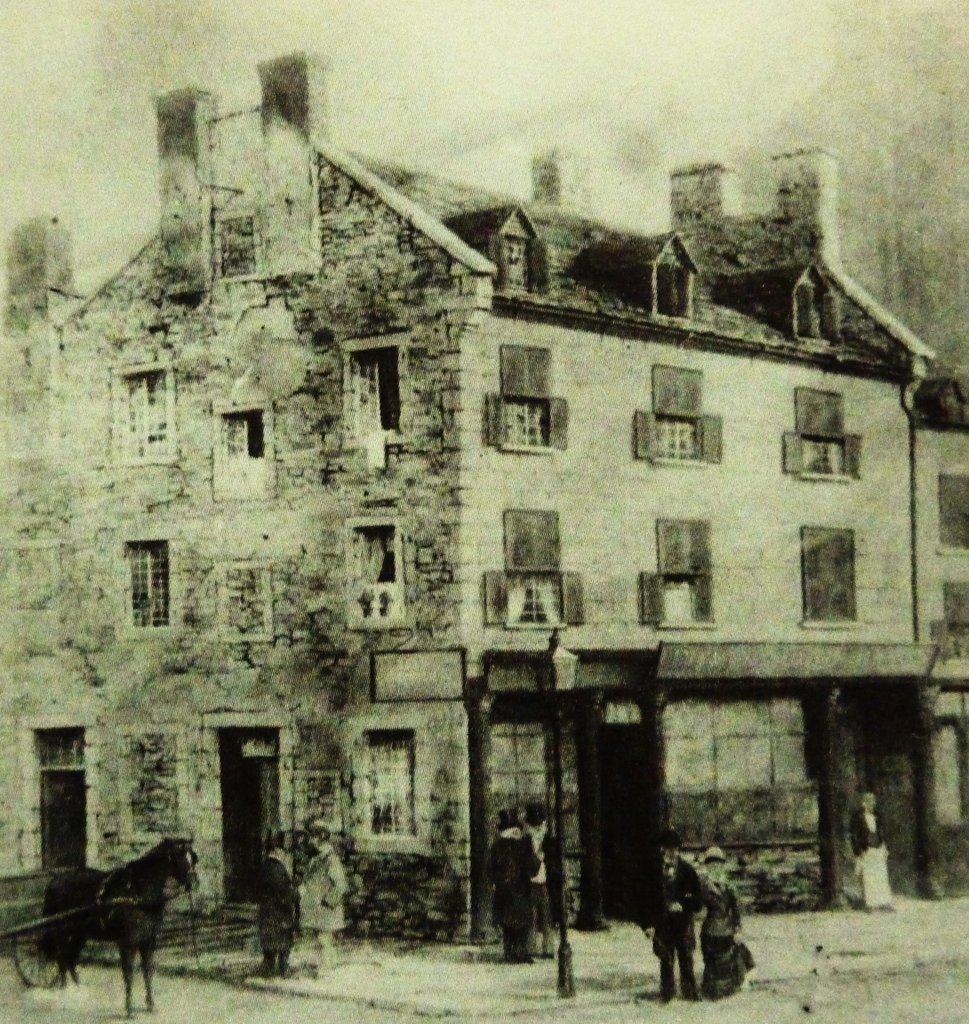Could you give a brief overview of what you see in this image? In this image I can see few people standing in-front of the building. I can also see the light pole to the side of these people. To the left I can see an animal. In the background there is a building with windows. I can also see the sky in the back. And this is a black and white image. 